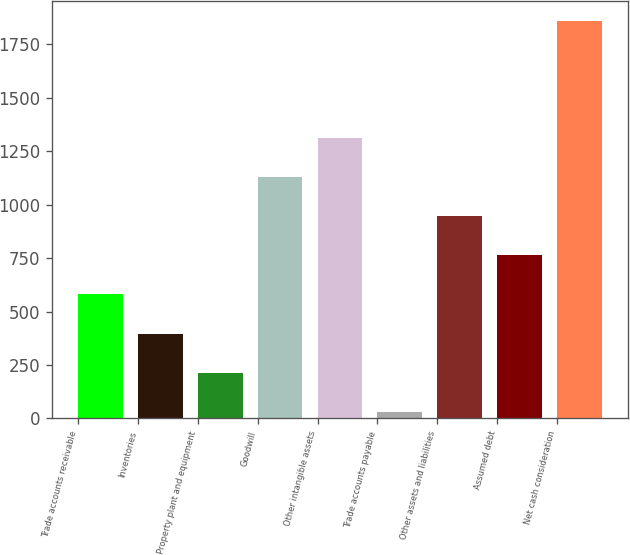Convert chart to OTSL. <chart><loc_0><loc_0><loc_500><loc_500><bar_chart><fcel>Trade accounts receivable<fcel>Inventories<fcel>Property plant and equipment<fcel>Goodwill<fcel>Other intangible assets<fcel>Trade accounts payable<fcel>Other assets and liabilities<fcel>Assumed debt<fcel>Net cash consideration<nl><fcel>580.07<fcel>396.98<fcel>213.89<fcel>1129.34<fcel>1312.43<fcel>30.8<fcel>946.25<fcel>763.16<fcel>1861.7<nl></chart> 